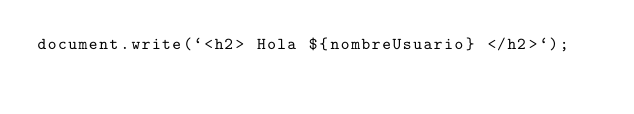Convert code to text. <code><loc_0><loc_0><loc_500><loc_500><_JavaScript_>document.write(`<h2> Hola ${nombreUsuario} </h2>`);
</code> 